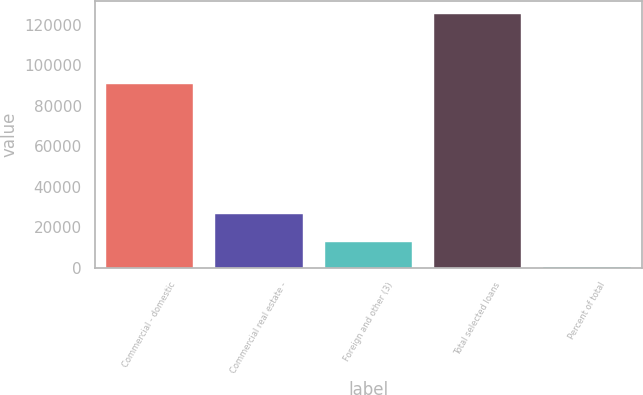Convert chart to OTSL. <chart><loc_0><loc_0><loc_500><loc_500><bar_chart><fcel>Commercial - domestic<fcel>Commercial real estate -<fcel>Foreign and other (3)<fcel>Total selected loans<fcel>Percent of total<nl><fcel>90528<fcel>26463<fcel>12572.5<fcel>125352<fcel>41.5<nl></chart> 